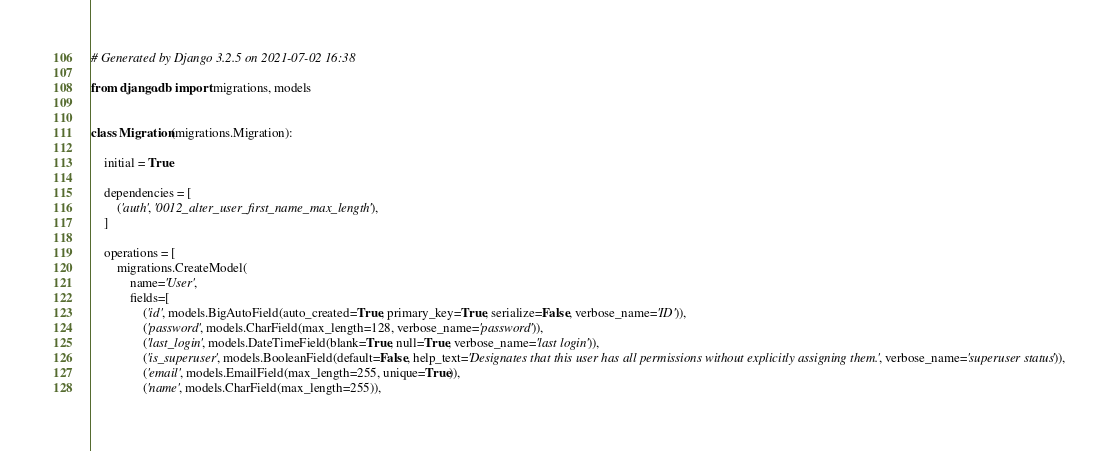<code> <loc_0><loc_0><loc_500><loc_500><_Python_># Generated by Django 3.2.5 on 2021-07-02 16:38

from django.db import migrations, models


class Migration(migrations.Migration):

    initial = True

    dependencies = [
        ('auth', '0012_alter_user_first_name_max_length'),
    ]

    operations = [
        migrations.CreateModel(
            name='User',
            fields=[
                ('id', models.BigAutoField(auto_created=True, primary_key=True, serialize=False, verbose_name='ID')),
                ('password', models.CharField(max_length=128, verbose_name='password')),
                ('last_login', models.DateTimeField(blank=True, null=True, verbose_name='last login')),
                ('is_superuser', models.BooleanField(default=False, help_text='Designates that this user has all permissions without explicitly assigning them.', verbose_name='superuser status')),
                ('email', models.EmailField(max_length=255, unique=True)),
                ('name', models.CharField(max_length=255)),</code> 